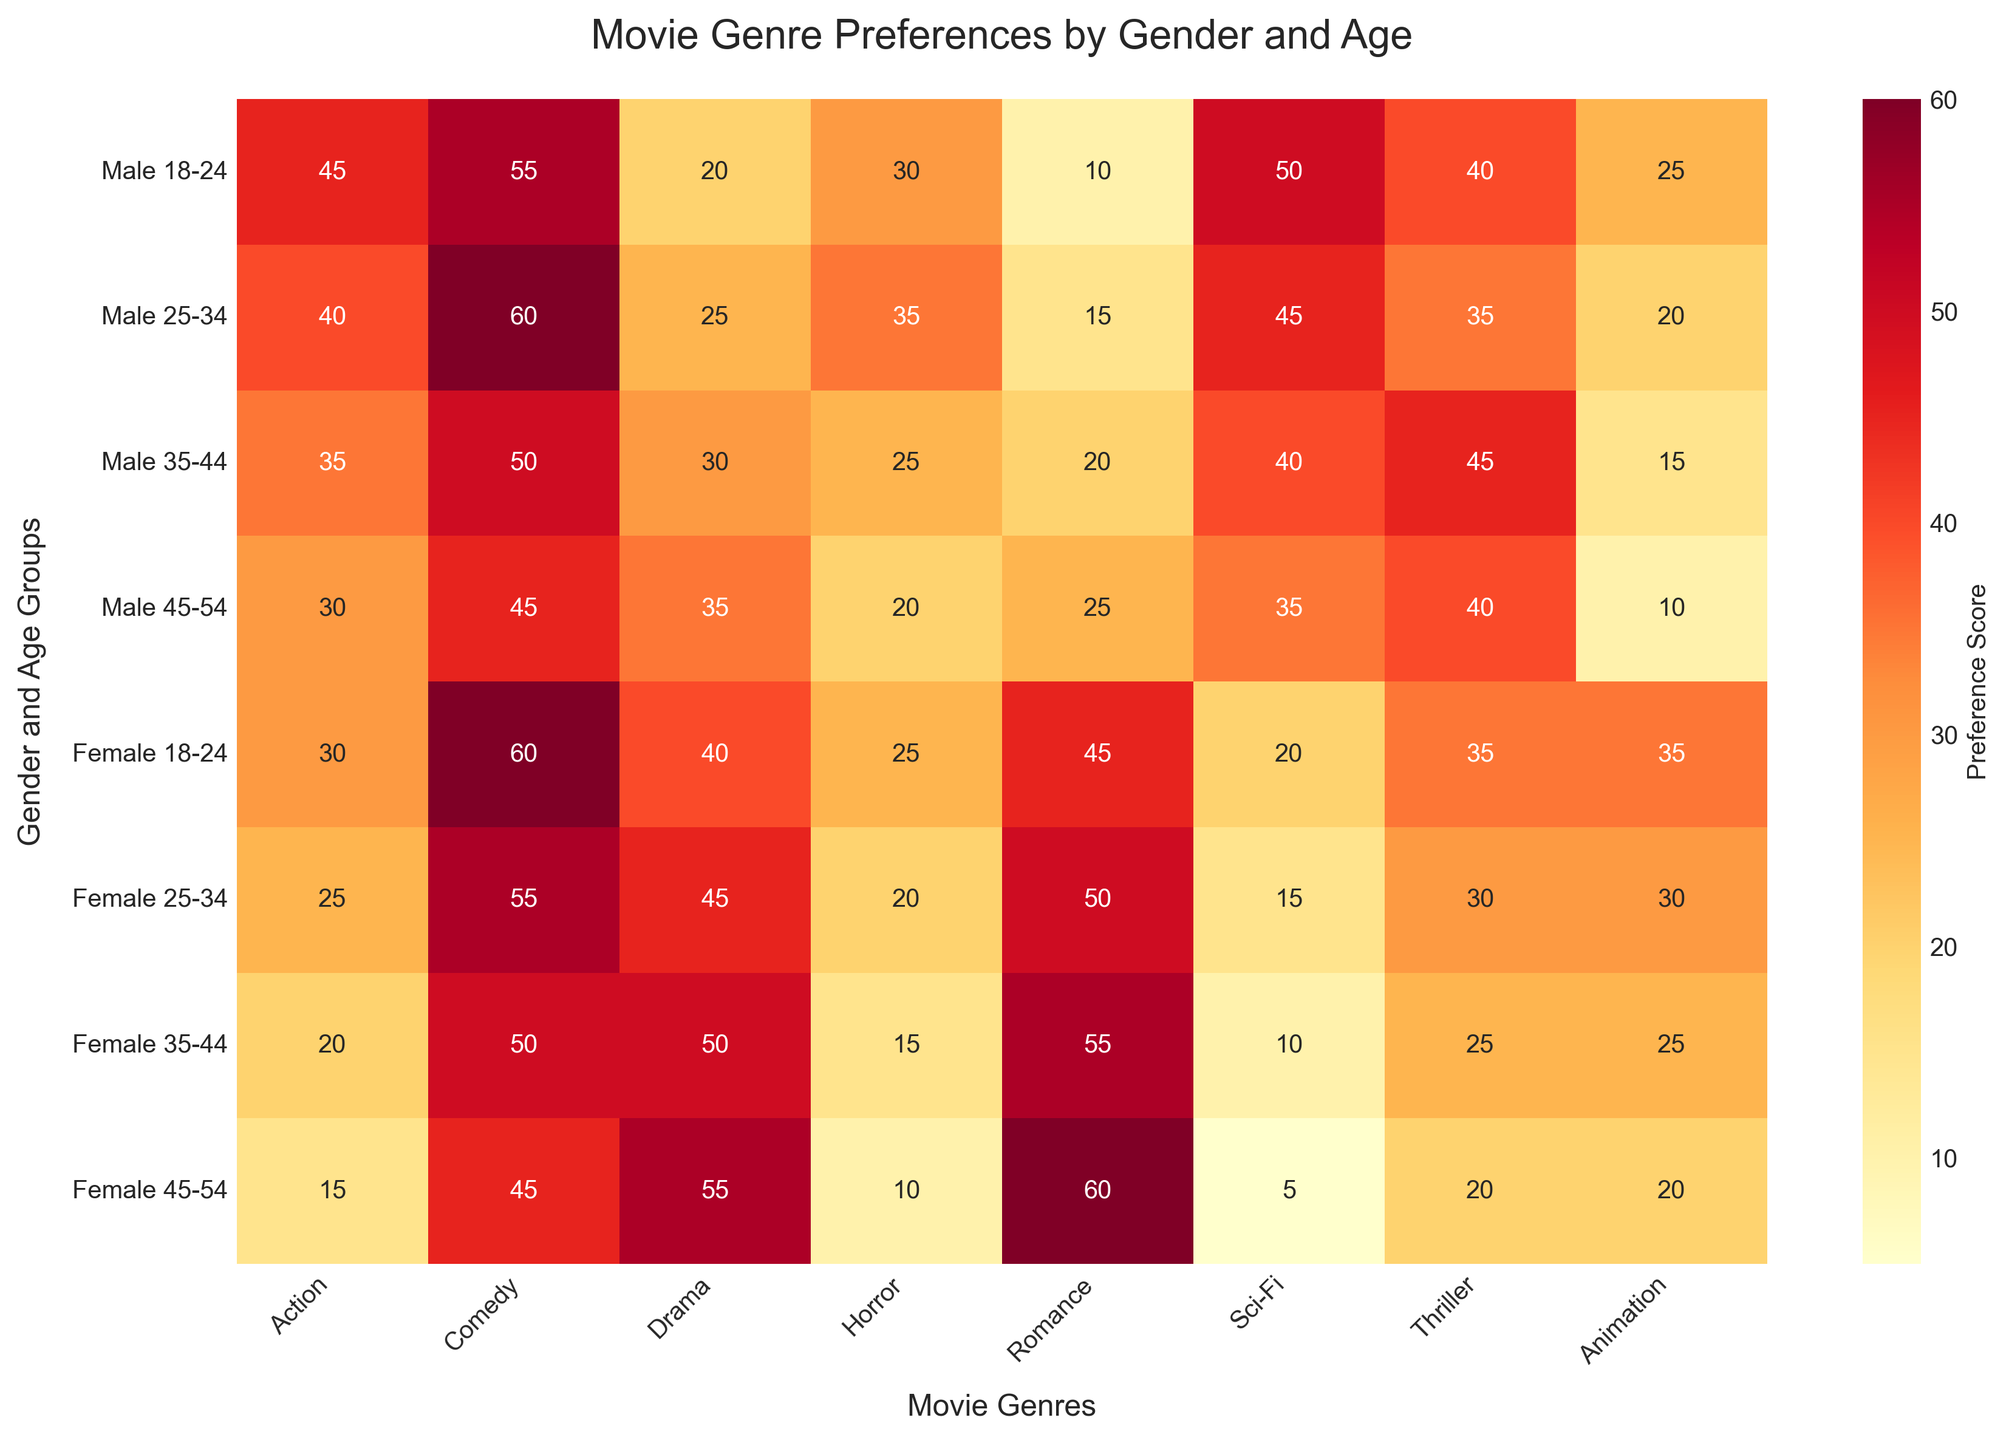What's the title of the heatmap? The title is usually placed at the top of the heatmap and can be identified by its larger, bold font. From there, we can see the heatmap is titled "Movie Genre Preferences by Gender and Age".
Answer: Movie Genre Preferences by Gender and Age Which gender and age group has the highest preference for Comedy? To find this, we scan through the column under "Comedy" to locate the highest value, then trace back to the corresponding row label. The highest value in the Comedy column is 60, recorded by both Male (25-34) and Female (18-24).
Answer: Male (25-34) and Female (18-24) What is the difference in preference for Action between males aged 18-24 and males aged 35-44? Locate the values in the Action column for both Male (18-24) and Male (35-44) groups. These values are 45 and 35, respectively. The difference is found by subtracting the smaller value from the larger one: 45 - 35 = 10.
Answer: 10 Which gender and age group has the lowest preference for Sci-Fi? Look for the lowest value in the Sci-Fi column and then find the corresponding row label. The lowest value in the Sci-Fi column is 5, recorded by Female (45-54).
Answer: Female (45-54) How does the preference for Romance vary among females from age group 18-24 to 45-54? Identify values for Romance in the rows corresponding to "Female". The values are: Female (18-24): 45, Female (25-34): 50, Female (35-44): 55, Female (45-54): 60. This shows an increasing trend.
Answer: Increases Which age group has the highest combined preference score for Thriller across both genders? To find this, calculate the total preference score for Thriller for each age group by summing the male and female preference values in each age group. The totals are:
- (18-24): 40 (Male) + 35 (Female) = 75
- (25-34): 35 (Male) + 30 (Female) = 65
- (35-44): 45 (Male) + 25 (Female) = 70
- (45-54): 40 (Male) + 20 (Female) = 60
The highest combined score is for the age group 18-24 with 75.
Answer: 18-24 What is the average preference for Horror among males? Locate the values in the Horror column for the male rows, which are 30, 35, 25, and 20. Sum these values and divide by the number of values: (30 + 35 + 25 + 20) / 4 = 110 / 4 = 27.5.
Answer: 27.5 Is the preference for Animation higher in females aged 18-24 or males aged 25-34? Compare the Animation values for these two groups: Female (18-24) has a value of 35 and Male (25-34) has a value of 20. 35 is greater than 20.
Answer: Females aged 18-24 